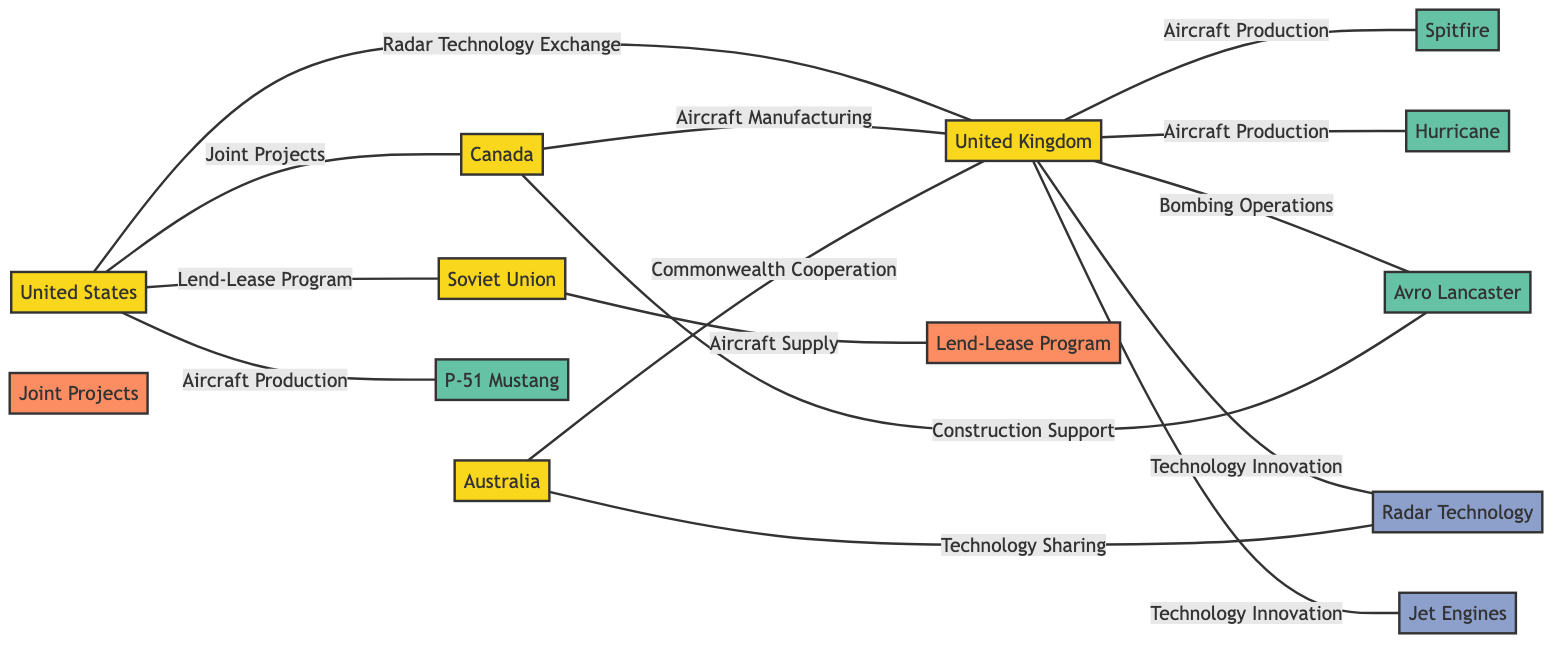What is the total number of countries in the graph? The graph contains five nodes representing countries: United States, United Kingdom, Soviet Union, Canada, and Australia. Counting these nodes gives a total of five countries.
Answer: 5 Which country collaborates with the United Kingdom on Radar Technology? The United States collaborates with the United Kingdom on Radar Technology, as indicated by the edge labeled "Radar Technology Exchange" connecting them.
Answer: United States How many aircraft are produced by the United Kingdom? The United Kingdom produces three types of aircraft according to the edges labeled "Aircraft Production": Spitfire, Hurricane, and Lend-Lease Program. Counting these gives a total of three aircraft produced.
Answer: 3 Which country is involved in the construction support of the Avro Lancaster? Canada is indicated as providing construction support to the Avro Lancaster, as shown by the edge labeled "Construction Support" connecting Canada and Avro Lancaster.
Answer: Canada What is the primary collaborative program between the United States and Soviet Union? The primary collaborative program between the United States and Soviet Union is the Lend-Lease Program, as it is represented by the edge labeled "Lend-Lease Program" connecting these two countries.
Answer: Lend-Lease Program Which countries share technology innovation with the United Kingdom? The United Kingdom shares technology innovation with the United States and Australia. The edges labeled "Technology Innovation" leading to Radar Technology and Jet Engines indicate this.
Answer: United States, Australia What role does Australia play in the collaboration with the United Kingdom? Australia plays a role in Commonwealth Cooperation and Technology Sharing with the United Kingdom, as indicated by the edges connecting Australia to the United Kingdom for both collaborative efforts.
Answer: Commonwealth Cooperation, Technology Sharing Which technology is connected to both the United Kingdom and Australia? Radar Technology is connected to both the United Kingdom and Australia. There are edges showing "Technology Innovation" from the United Kingdom and "Technology Sharing" from Australia to Radar Technology.
Answer: Radar Technology How many aircraft are involved in the collaborative projects between the United States and Canada? The collaborative projects between the United States and Canada involve two aircraft, the P-51 Mustang and Avro Lancaster, according to the edges labeled "Aircraft Production" and "Construction Support." Counting these gives a total of two aircraft.
Answer: 2 